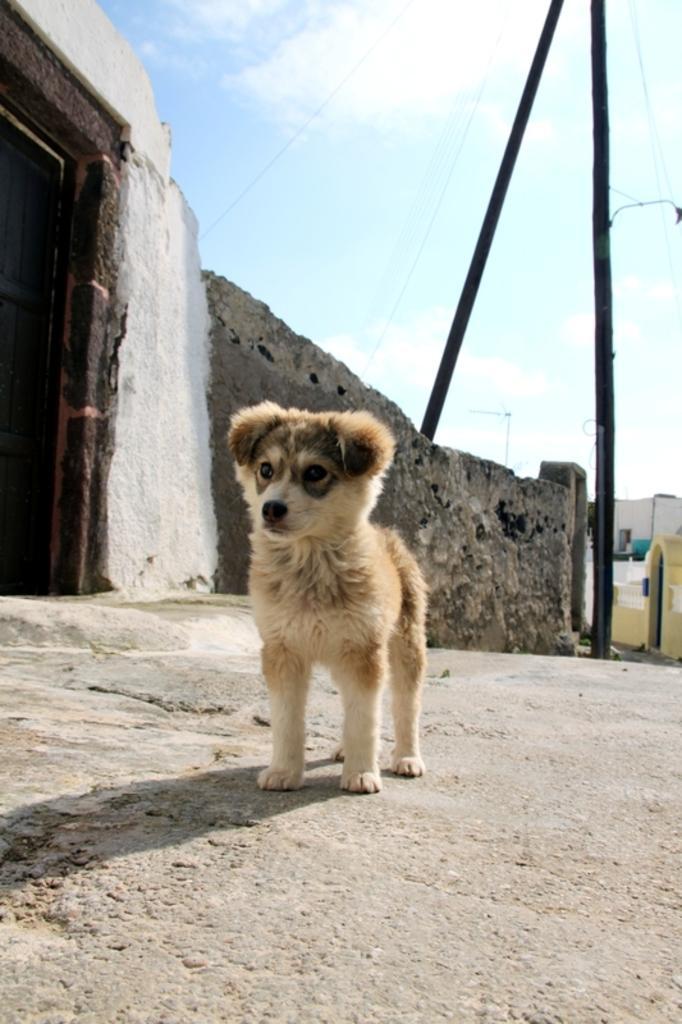Could you give a brief overview of what you see in this image? In this image we can see a dog on the road. Here we can see wall, door, poles, and a house. In the background there is sky with clouds. 